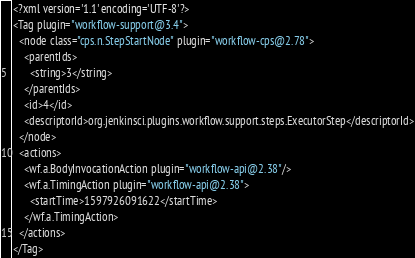<code> <loc_0><loc_0><loc_500><loc_500><_XML_><?xml version='1.1' encoding='UTF-8'?>
<Tag plugin="workflow-support@3.4">
  <node class="cps.n.StepStartNode" plugin="workflow-cps@2.78">
    <parentIds>
      <string>3</string>
    </parentIds>
    <id>4</id>
    <descriptorId>org.jenkinsci.plugins.workflow.support.steps.ExecutorStep</descriptorId>
  </node>
  <actions>
    <wf.a.BodyInvocationAction plugin="workflow-api@2.38"/>
    <wf.a.TimingAction plugin="workflow-api@2.38">
      <startTime>1597926091622</startTime>
    </wf.a.TimingAction>
  </actions>
</Tag></code> 